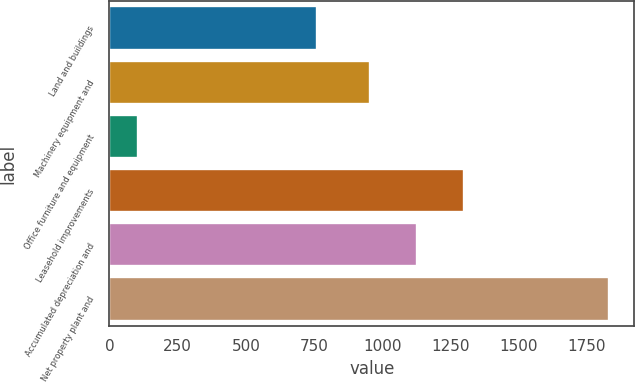Convert chart. <chart><loc_0><loc_0><loc_500><loc_500><bar_chart><fcel>Land and buildings<fcel>Machinery equipment and<fcel>Office furniture and equipment<fcel>Leasehold improvements<fcel>Accumulated depreciation and<fcel>Net property plant and<nl><fcel>762<fcel>954<fcel>106<fcel>1299.2<fcel>1126.6<fcel>1832<nl></chart> 